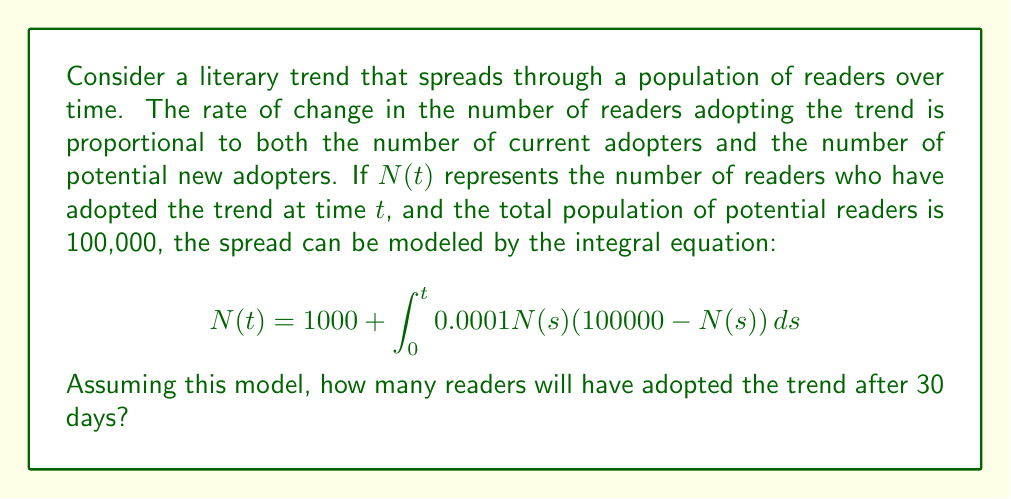Give your solution to this math problem. To solve this integral equation, we'll follow these steps:

1) First, we recognize this as a logistic growth model, where the initial number of adopters is 1000, and the carrying capacity is 100,000.

2) The differential form of this equation is:

   $$\frac{dN}{dt} = 0.0001N(100000 - N)$$

3) This is a separable differential equation. We can solve it as follows:

   $$\int \frac{dN}{N(100000 - N)} = \int 0.0001 dt$$

4) The left side can be decomposed using partial fractions:

   $$\int (\frac{1}{100000N} + \frac{1}{100000(100000 - N)}) dN = 0.0001t + C$$

5) Integrating both sides:

   $$\frac{1}{100000}[\ln|N| - \ln|100000 - N|] = 0.0001t + C$$

6) Simplifying and applying the initial condition $N(0) = 1000$:

   $$\ln(\frac{N}{100000 - N}) = 10t + \ln(\frac{1000}{99000})$$

7) Solving for $N$:

   $$N = \frac{100000}{1 + 99e^{-10t}}$$

8) Now we can find $N(30)$ by plugging in $t = 30$:

   $$N(30) = \frac{100000}{1 + 99e^{-300}} \approx 99999.9999$$

9) Rounding to the nearest whole number of readers:

   $$N(30) \approx 100000$$
Answer: 100000 readers 